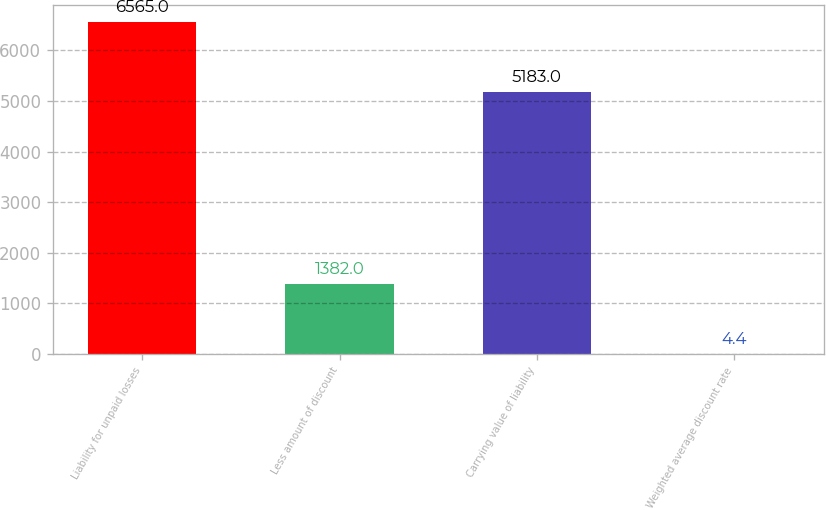Convert chart. <chart><loc_0><loc_0><loc_500><loc_500><bar_chart><fcel>Liability for unpaid losses<fcel>Less amount of discount<fcel>Carrying value of liability<fcel>Weighted average discount rate<nl><fcel>6565<fcel>1382<fcel>5183<fcel>4.4<nl></chart> 